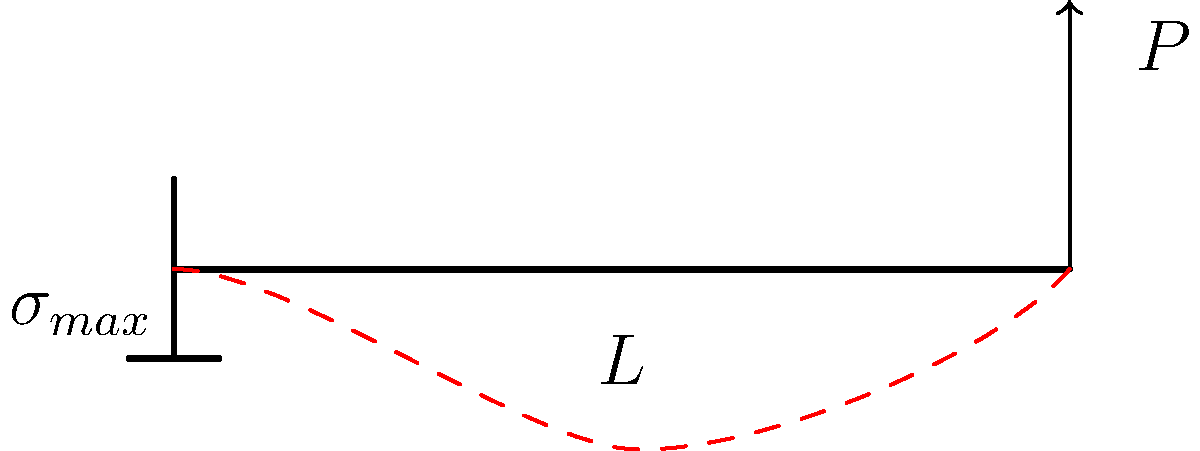Consider a cantilever beam of length $L$ with a point load $P$ applied at its free end. Given that the maximum bending stress $\sigma_{max}$ occurs at the fixed end and is given by the equation $\sigma_{max} = \frac{6PL}{bh^2}$, where $b$ is the width and $h$ is the height of the beam's rectangular cross-section, derive an expression for the stress distribution $\sigma(x)$ along the length of the beam as a function of distance $x$ from the fixed end. To derive the stress distribution function $\sigma(x)$, we'll follow these steps:

1) First, recall that the bending moment $M(x)$ in a cantilever beam with a point load $P$ at the free end is given by:

   $M(x) = P(L-x)$

2) The general equation for bending stress at any point in a beam is:

   $\sigma = \frac{My}{I}$

   where $M$ is the bending moment, $y$ is the distance from the neutral axis, and $I$ is the moment of inertia of the cross-section.

3) For a rectangular cross-section, the moment of inertia $I$ is:

   $I = \frac{bh^3}{12}$

4) The maximum stress occurs at the outer fibers where $y = h/2$. Substituting this into the general equation:

   $\sigma_{max}(x) = \frac{M(x)(h/2)}{I} = \frac{P(L-x)(h/2)}{\frac{bh^3}{12}} = \frac{6P(L-x)}{bh^2}$

5) We can see that this equation matches the given equation for $\sigma_{max}$ when $x = 0$ (at the fixed end).

6) Therefore, the stress distribution $\sigma(x)$ along the length of the beam is:

   $\sigma(x) = \frac{6P(L-x)}{bh^2}$

This equation shows that the stress varies linearly from a maximum at the fixed end ($x = 0$) to zero at the free end ($x = L$).
Answer: $\sigma(x) = \frac{6P(L-x)}{bh^2}$ 